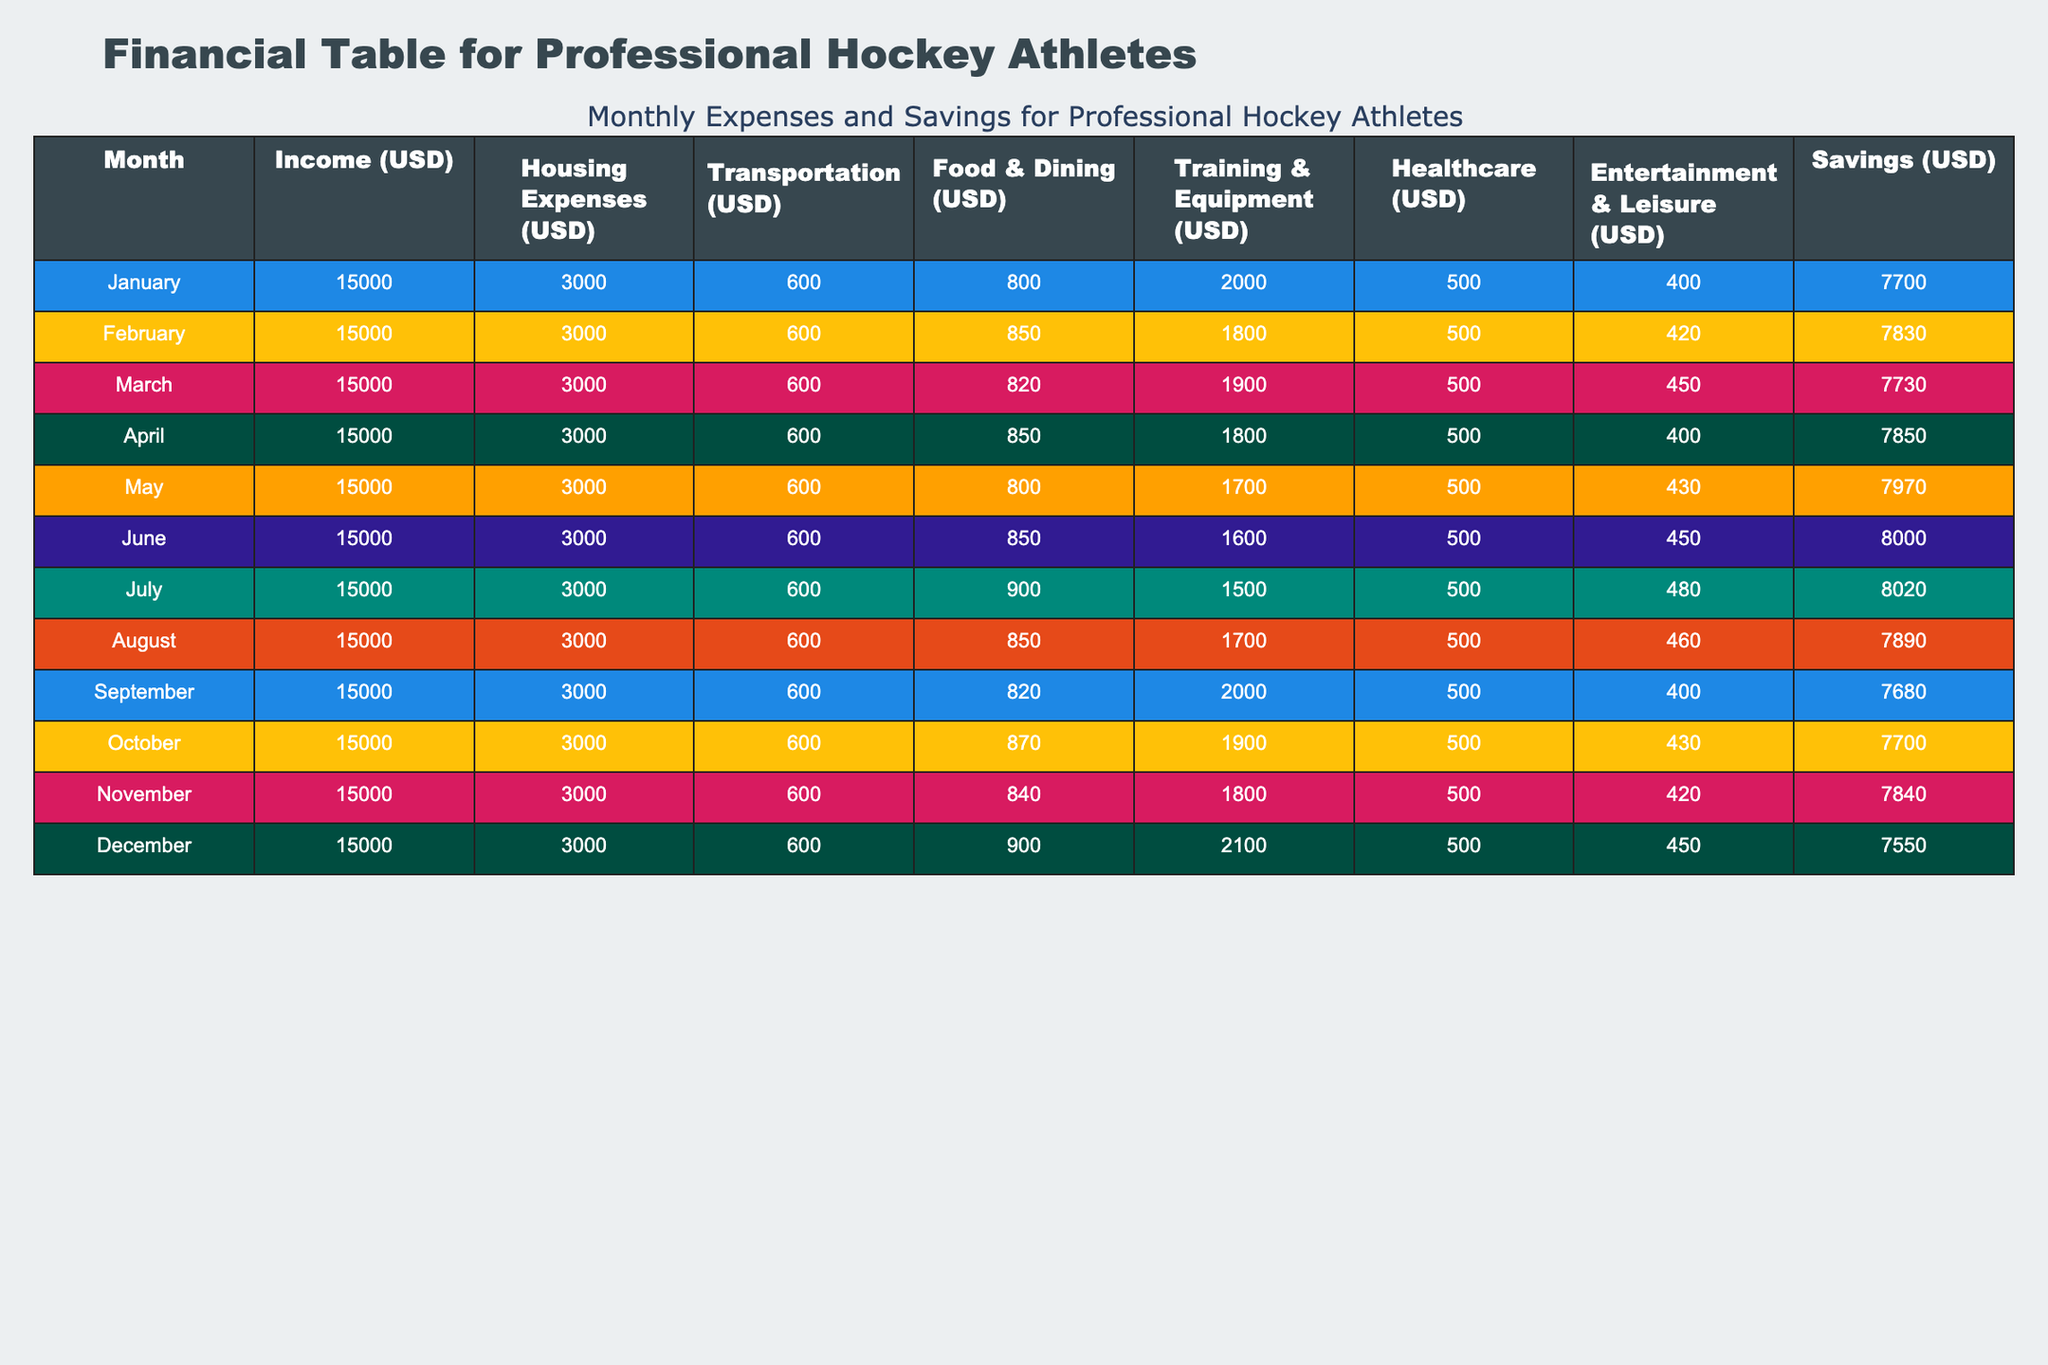What is the total monthly income for each month? The monthly income is constant at 15,000 USD for each month, so for all months, the total is 15,000 USD.
Answer: 15,000 USD In which month did the housing expenses peak? Reviewing the table, all months have identical housing expenses listed as 3,000 USD; thus, there’s no peak.
Answer: None peak, all are 3,000 USD What month had the highest savings? By examining the savings column, the highest value is 8,030 USD, recorded in July.
Answer: July What are the average food expenses per month? To calculate the average, sum the food expenses (800 + 850 + 820 + 850 + 800 + 850 + 900 + 850 + 820 + 870 + 840 + 900 = 10,390) and divide by 12 months: 10,390 / 12 = 866.58.
Answer: 866.58 USD Did healthcare expenses increase in any month compared to the previous month? Comparing the healthcare expenses month-by-month, there is an increase from December (2100) to November (1800) but not continuously; therefore, yes, there was one increase compared to the previous month.
Answer: Yes 